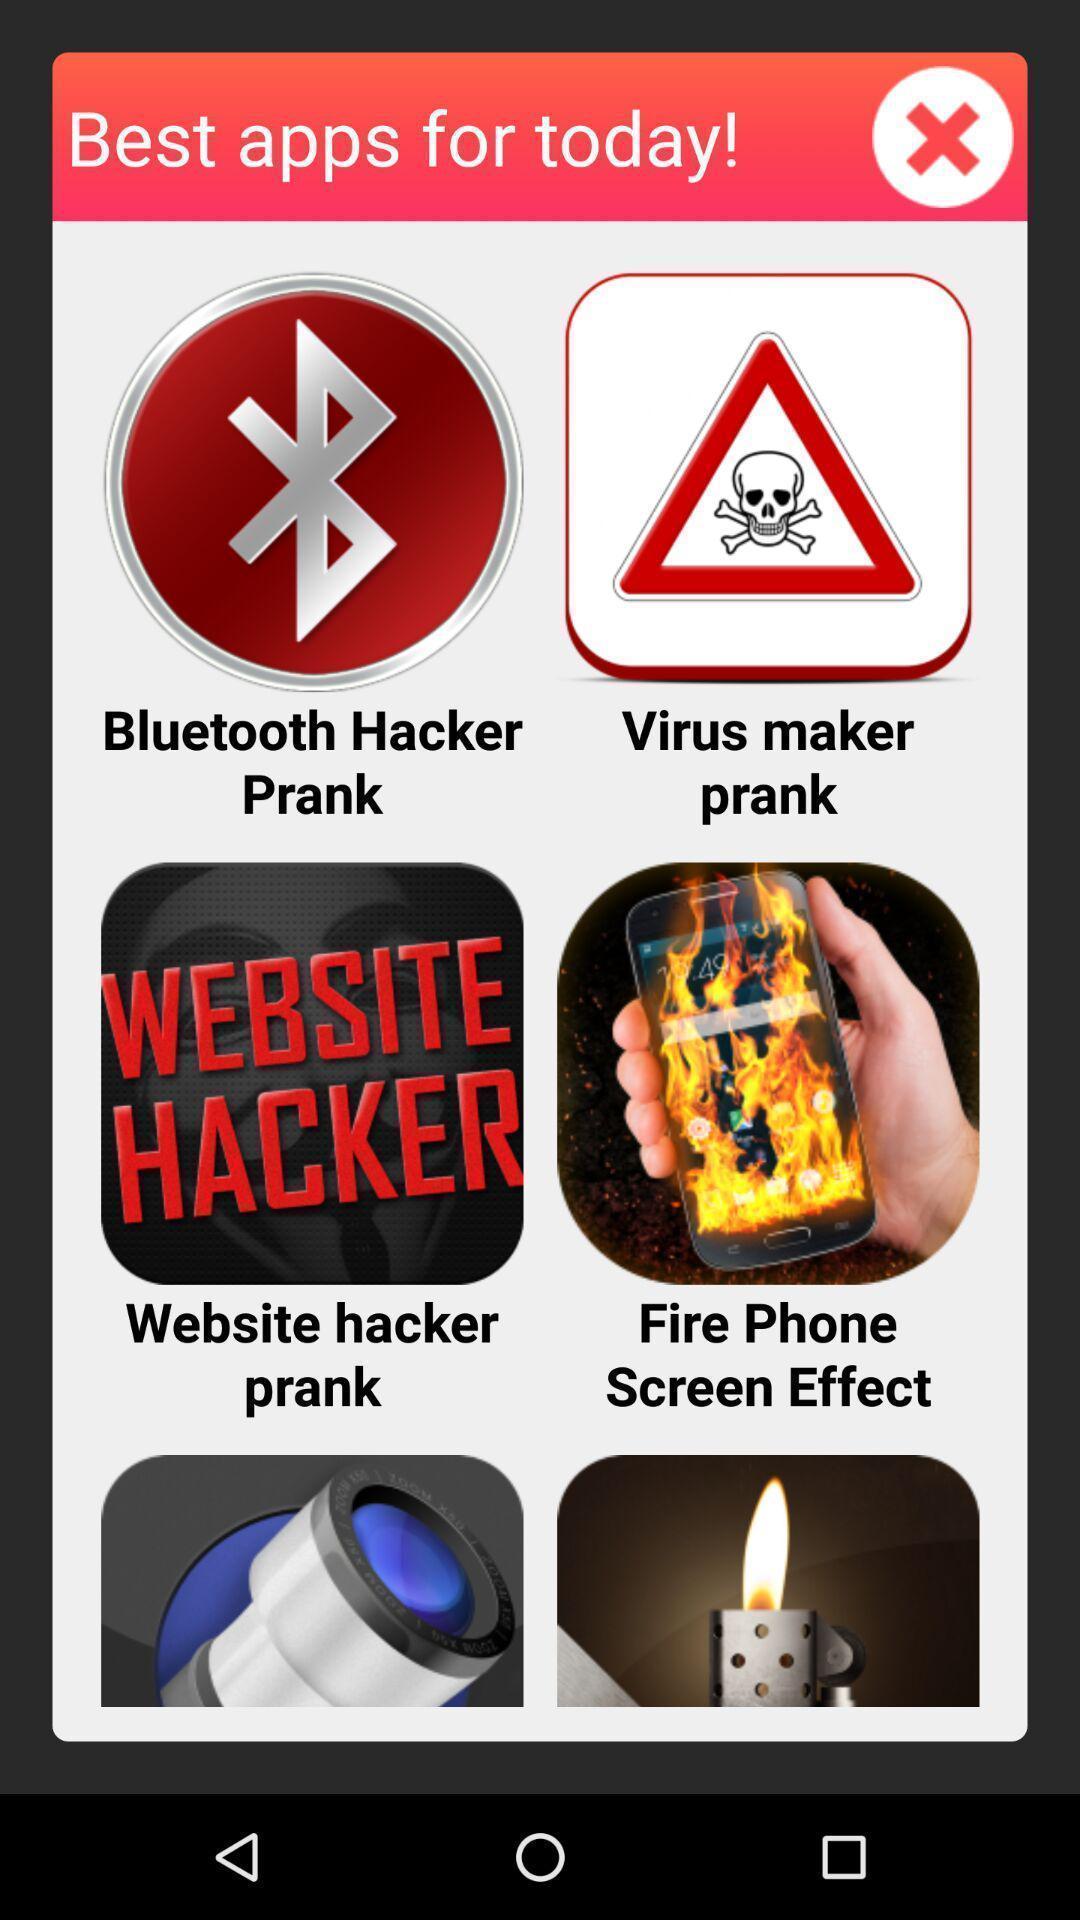What details can you identify in this image? Pop up message. 